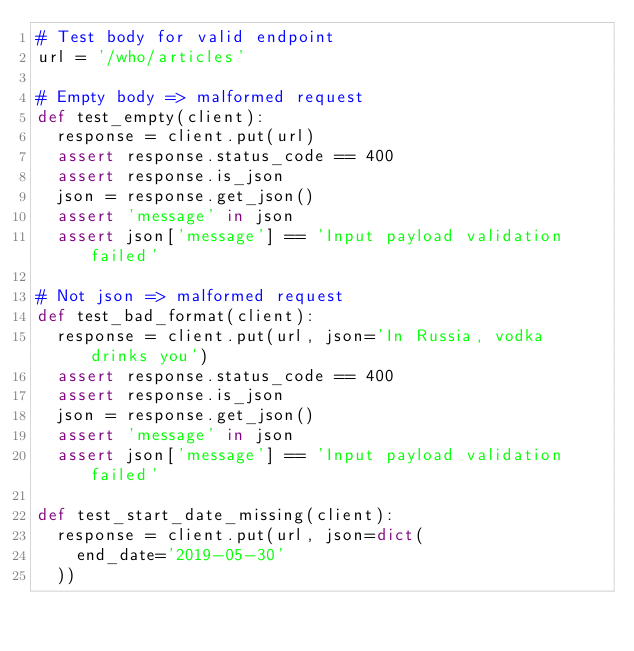Convert code to text. <code><loc_0><loc_0><loc_500><loc_500><_Python_># Test body for valid endpoint
url = '/who/articles'

# Empty body => malformed request 
def test_empty(client):
	response = client.put(url)
	assert response.status_code == 400
	assert response.is_json
	json = response.get_json()
	assert 'message' in json
	assert json['message'] == 'Input payload validation failed'

# Not json => malformed request 
def test_bad_format(client):
	response = client.put(url, json='In Russia, vodka drinks you')
	assert response.status_code == 400
	assert response.is_json
	json = response.get_json()
	assert 'message' in json
	assert json['message'] == 'Input payload validation failed'

def test_start_date_missing(client):
	response = client.put(url, json=dict(
		end_date='2019-05-30'
	))</code> 